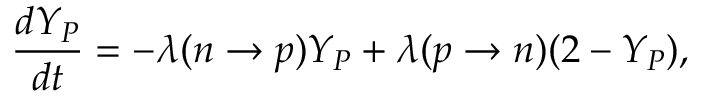<formula> <loc_0><loc_0><loc_500><loc_500>{ \frac { d Y _ { P } } { d t } } = - \lambda ( n \to p ) Y _ { P } + \lambda ( p \to n ) ( 2 - Y _ { P } ) ,</formula> 